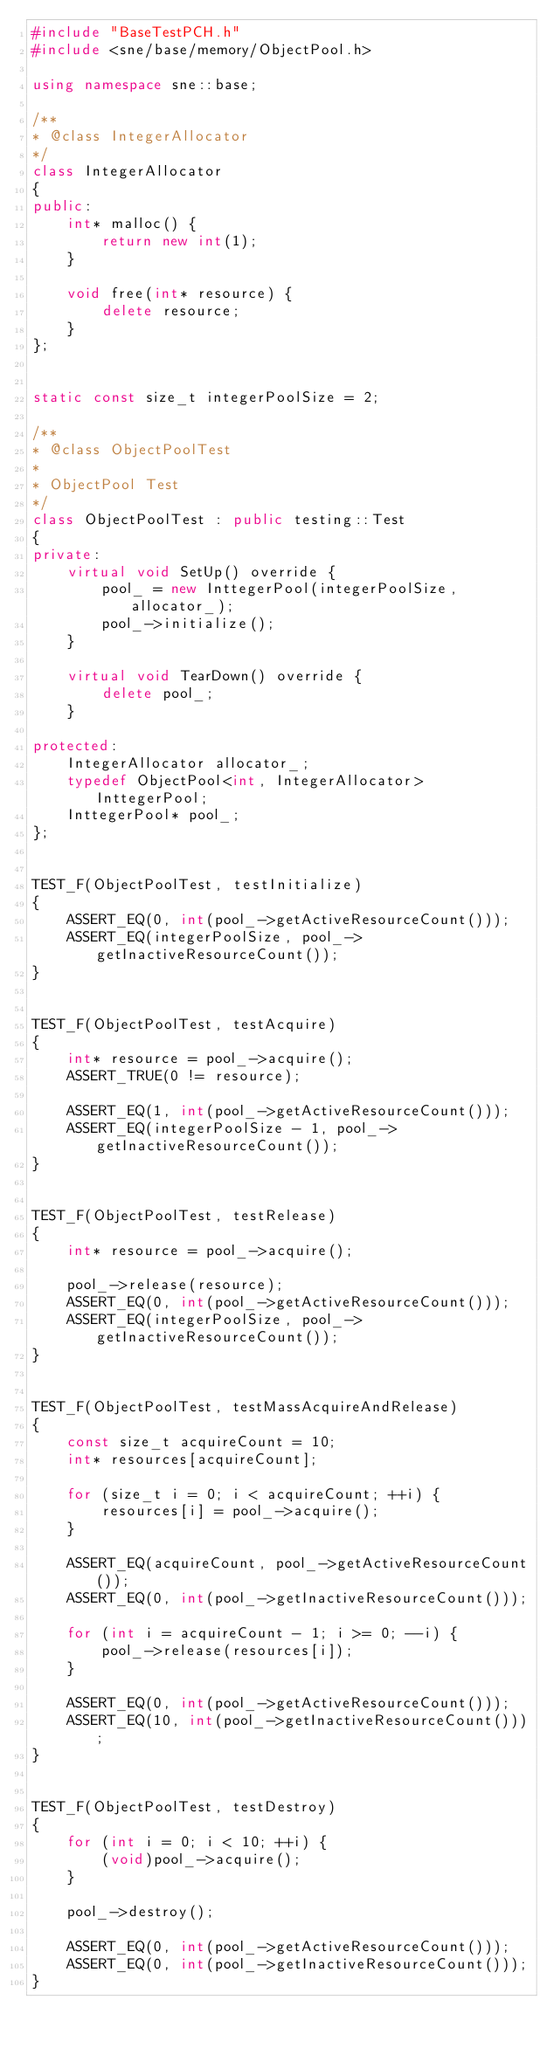<code> <loc_0><loc_0><loc_500><loc_500><_C++_>#include "BaseTestPCH.h"
#include <sne/base/memory/ObjectPool.h>

using namespace sne::base;

/**
* @class IntegerAllocator
*/
class IntegerAllocator
{
public:
    int* malloc() {
        return new int(1);
    }

    void free(int* resource) {
        delete resource;
    }
};


static const size_t integerPoolSize = 2;

/**
* @class ObjectPoolTest
*
* ObjectPool Test
*/
class ObjectPoolTest : public testing::Test
{
private:
    virtual void SetUp() override {
        pool_ = new InttegerPool(integerPoolSize, allocator_);
        pool_->initialize();
    }

    virtual void TearDown() override {
        delete pool_;
    }

protected:
    IntegerAllocator allocator_;
    typedef ObjectPool<int, IntegerAllocator> InttegerPool;
    InttegerPool* pool_;
};


TEST_F(ObjectPoolTest, testInitialize)
{
    ASSERT_EQ(0, int(pool_->getActiveResourceCount()));
    ASSERT_EQ(integerPoolSize, pool_->getInactiveResourceCount());
}


TEST_F(ObjectPoolTest, testAcquire)
{
    int* resource = pool_->acquire();
    ASSERT_TRUE(0 != resource);

    ASSERT_EQ(1, int(pool_->getActiveResourceCount()));
    ASSERT_EQ(integerPoolSize - 1, pool_->getInactiveResourceCount());
}


TEST_F(ObjectPoolTest, testRelease)
{
    int* resource = pool_->acquire();

    pool_->release(resource);
    ASSERT_EQ(0, int(pool_->getActiveResourceCount()));
    ASSERT_EQ(integerPoolSize, pool_->getInactiveResourceCount());
}


TEST_F(ObjectPoolTest, testMassAcquireAndRelease)
{
    const size_t acquireCount = 10;
    int* resources[acquireCount];

    for (size_t i = 0; i < acquireCount; ++i) {
        resources[i] = pool_->acquire();
    }

    ASSERT_EQ(acquireCount, pool_->getActiveResourceCount());
    ASSERT_EQ(0, int(pool_->getInactiveResourceCount()));

    for (int i = acquireCount - 1; i >= 0; --i) {
        pool_->release(resources[i]);
    }

    ASSERT_EQ(0, int(pool_->getActiveResourceCount()));
    ASSERT_EQ(10, int(pool_->getInactiveResourceCount()));
}


TEST_F(ObjectPoolTest, testDestroy)
{
    for (int i = 0; i < 10; ++i) {
        (void)pool_->acquire();
    }

    pool_->destroy();

    ASSERT_EQ(0, int(pool_->getActiveResourceCount()));
    ASSERT_EQ(0, int(pool_->getInactiveResourceCount()));
}

</code> 